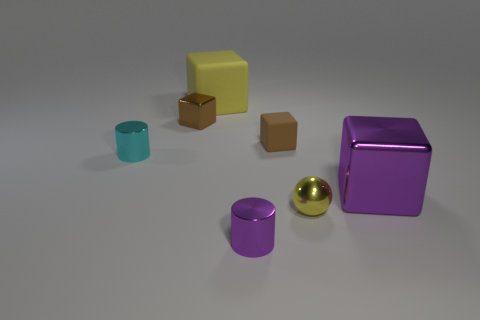Subtract 1 blocks. How many blocks are left? 3 Subtract all yellow cubes. How many cubes are left? 3 Add 1 big gray things. How many objects exist? 8 Subtract all blue cubes. Subtract all red spheres. How many cubes are left? 4 Subtract all cylinders. How many objects are left? 5 Add 4 green metal balls. How many green metal balls exist? 4 Subtract 0 green blocks. How many objects are left? 7 Subtract all cyan shiny cylinders. Subtract all big metallic objects. How many objects are left? 5 Add 7 big purple blocks. How many big purple blocks are left? 8 